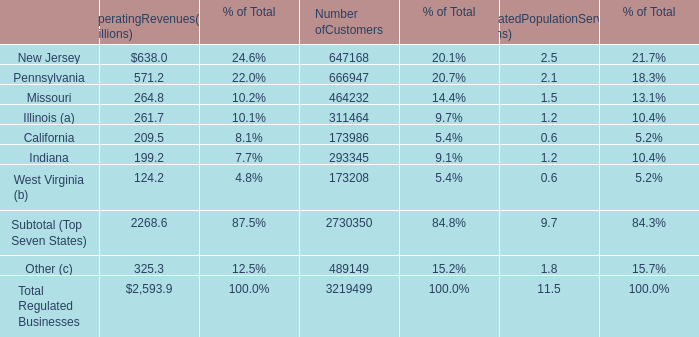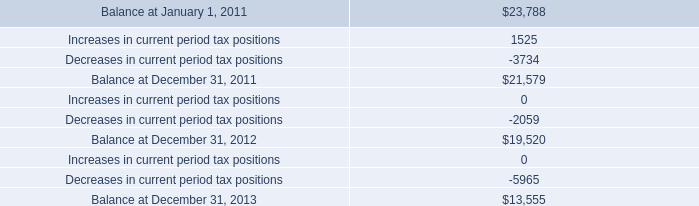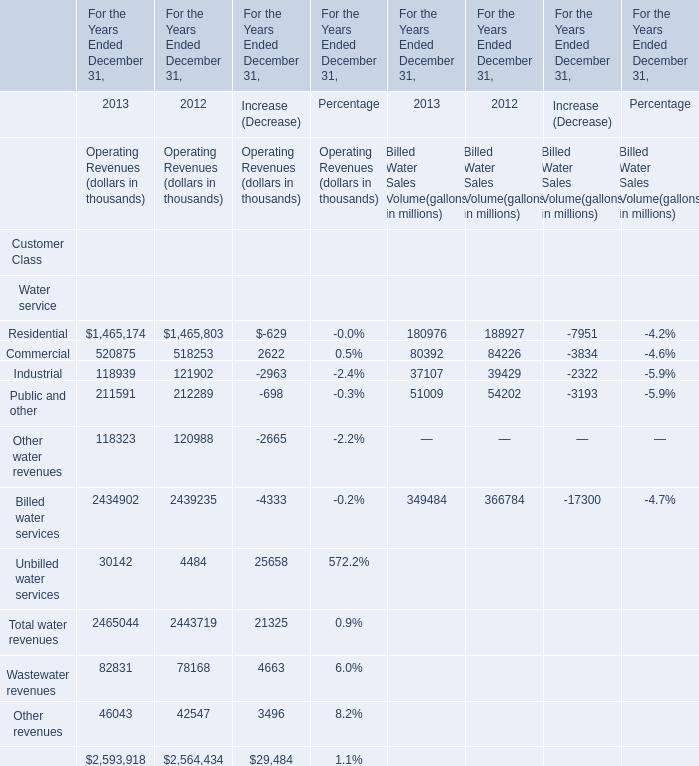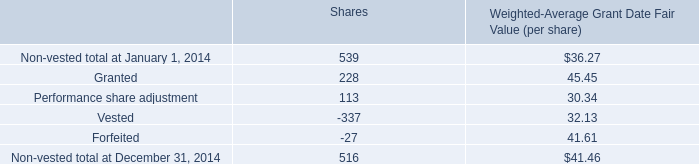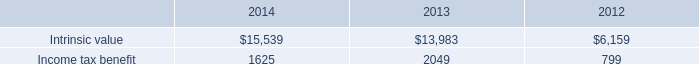what is the percentage of the discrete ax benefit as a part of the balance at december 312013 
Computations: (2979 / 13555)
Answer: 0.21977. 